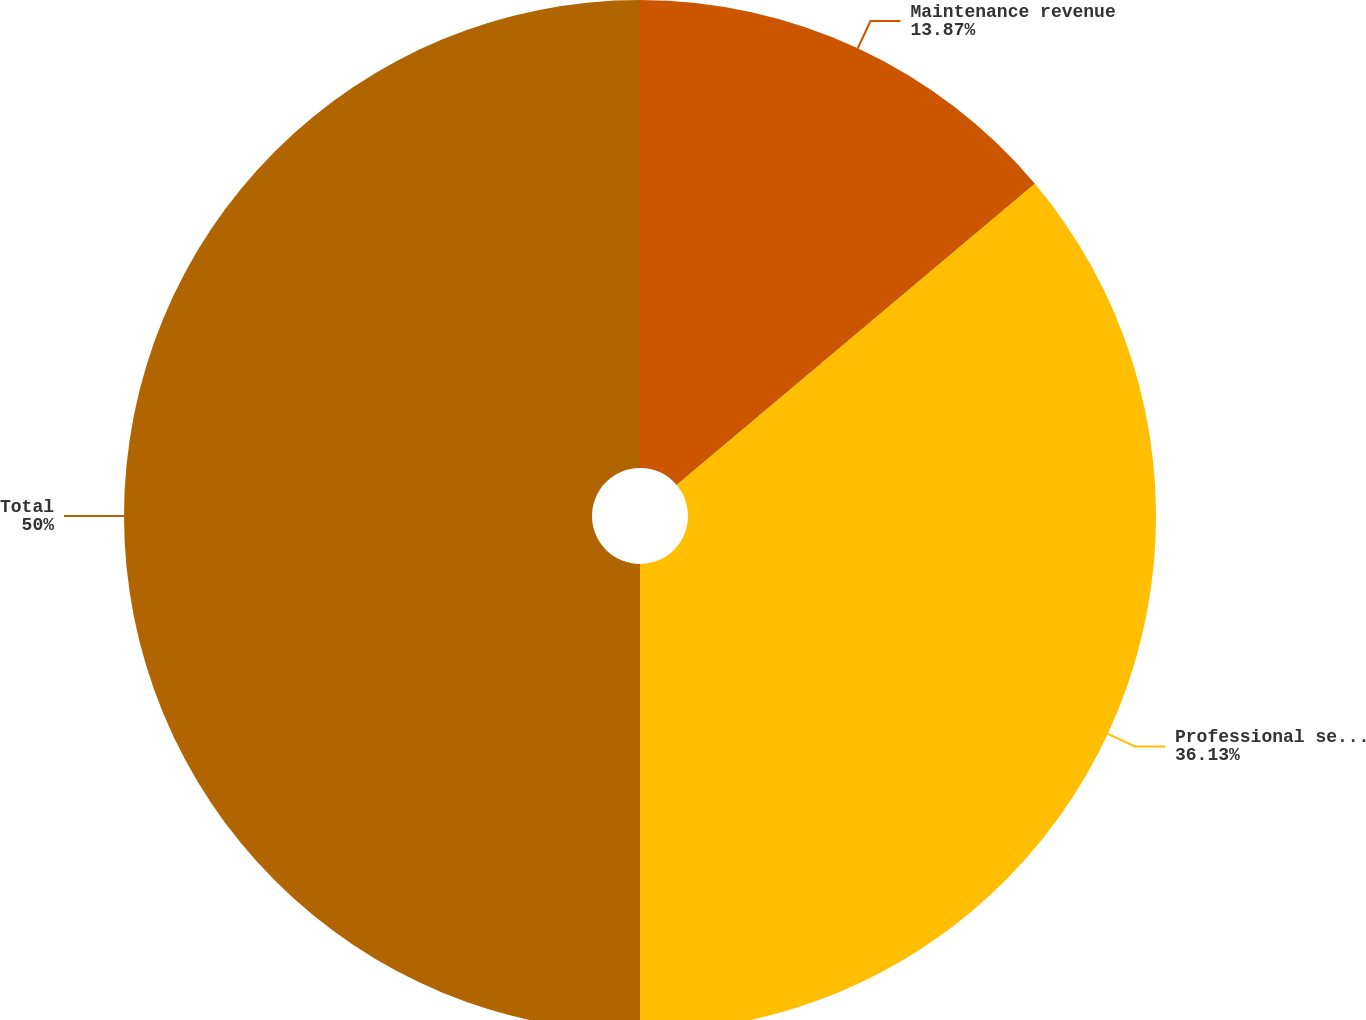Convert chart. <chart><loc_0><loc_0><loc_500><loc_500><pie_chart><fcel>Maintenance revenue<fcel>Professional service and other<fcel>Total<nl><fcel>13.87%<fcel>36.13%<fcel>50.0%<nl></chart> 